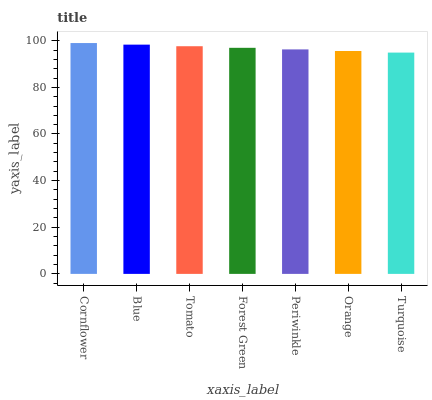Is Turquoise the minimum?
Answer yes or no. Yes. Is Cornflower the maximum?
Answer yes or no. Yes. Is Blue the minimum?
Answer yes or no. No. Is Blue the maximum?
Answer yes or no. No. Is Cornflower greater than Blue?
Answer yes or no. Yes. Is Blue less than Cornflower?
Answer yes or no. Yes. Is Blue greater than Cornflower?
Answer yes or no. No. Is Cornflower less than Blue?
Answer yes or no. No. Is Forest Green the high median?
Answer yes or no. Yes. Is Forest Green the low median?
Answer yes or no. Yes. Is Blue the high median?
Answer yes or no. No. Is Periwinkle the low median?
Answer yes or no. No. 